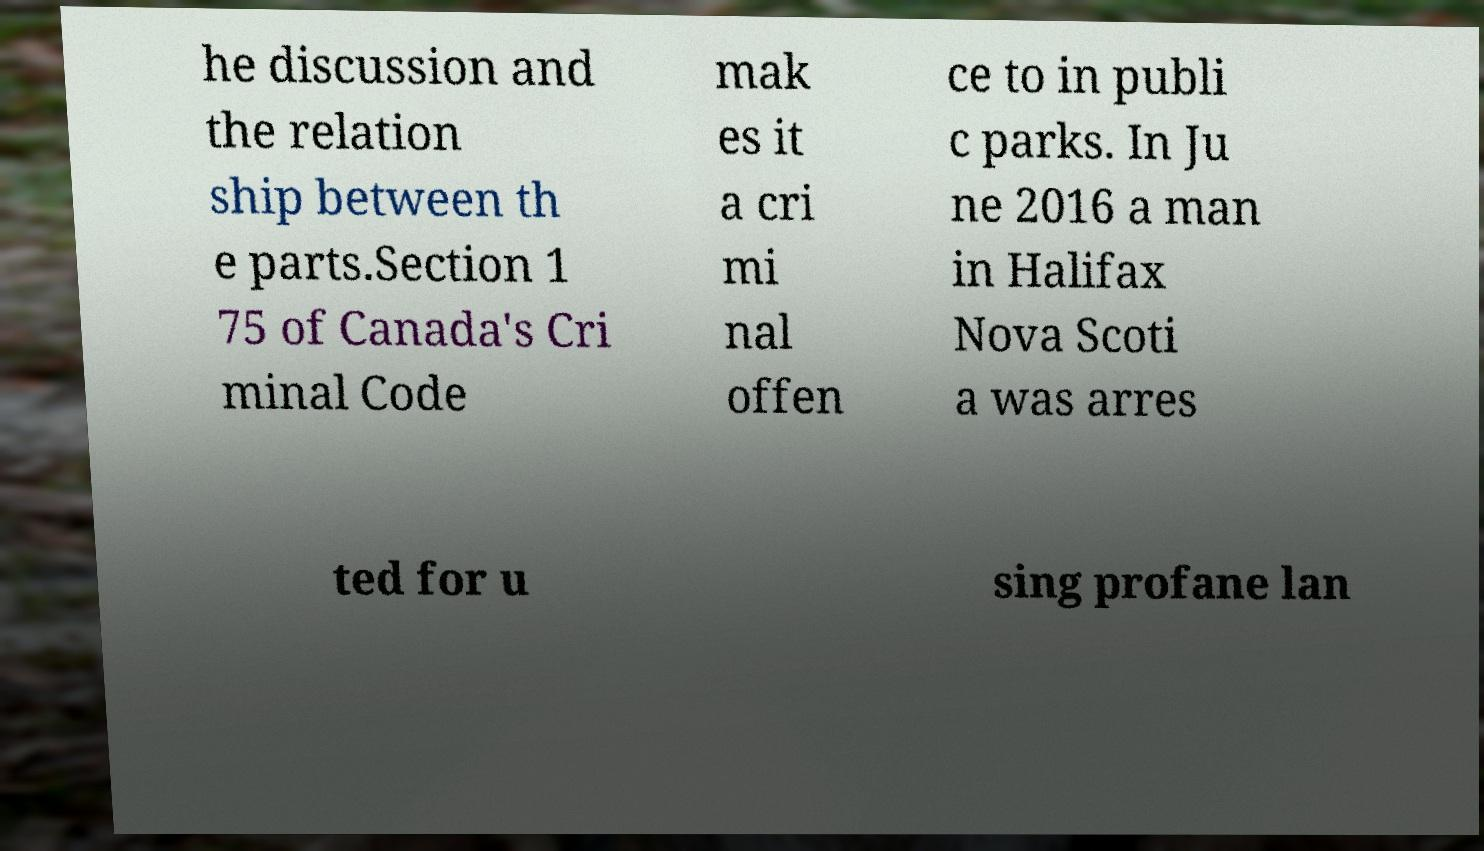Please read and relay the text visible in this image. What does it say? he discussion and the relation ship between th e parts.Section 1 75 of Canada's Cri minal Code mak es it a cri mi nal offen ce to in publi c parks. In Ju ne 2016 a man in Halifax Nova Scoti a was arres ted for u sing profane lan 